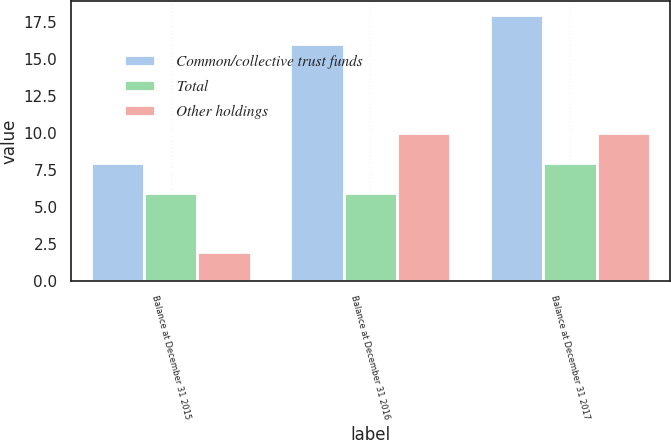<chart> <loc_0><loc_0><loc_500><loc_500><stacked_bar_chart><ecel><fcel>Balance at December 31 2015<fcel>Balance at December 31 2016<fcel>Balance at December 31 2017<nl><fcel>Common/collective trust funds<fcel>8<fcel>16<fcel>18<nl><fcel>Total<fcel>6<fcel>6<fcel>8<nl><fcel>Other holdings<fcel>2<fcel>10<fcel>10<nl></chart> 